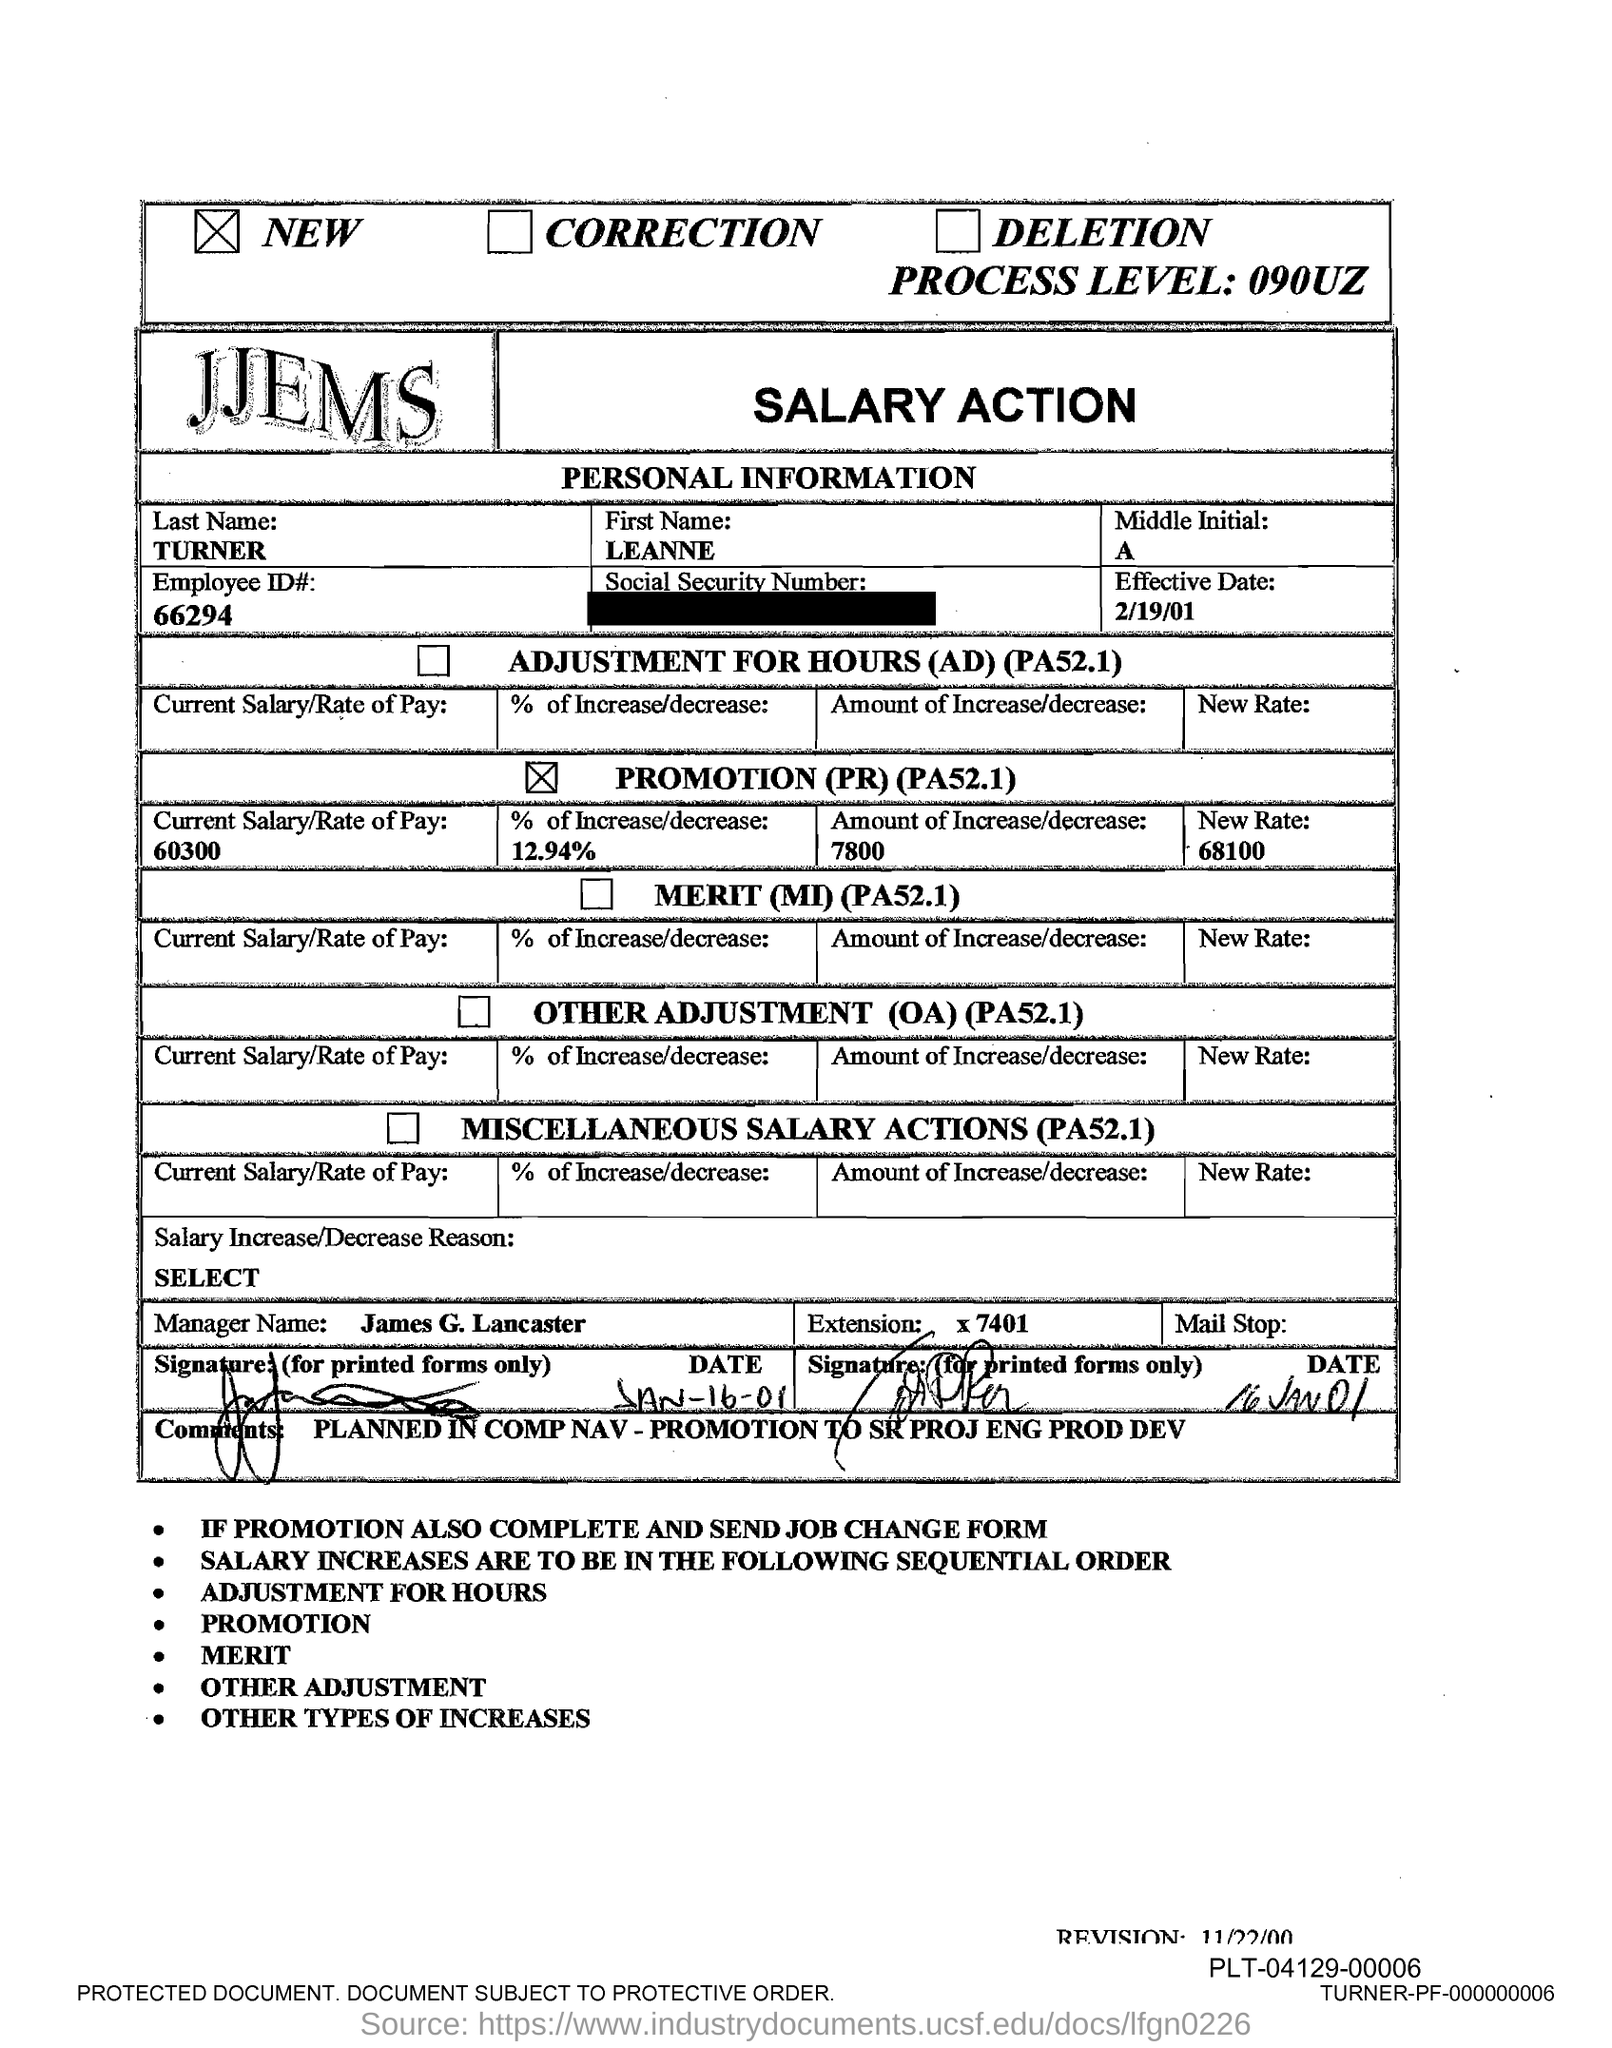What is the first name of the employee given in the document?
Your answer should be very brief. LEANNE. What is the Employee ID# given in the document?
Provide a succinct answer. 66294. What is the Effective Date mentioned in this document?
Provide a succinct answer. 2/19/01. What is the manager's name mentioned in the document?
Your response must be concise. James G. Lancaster. 